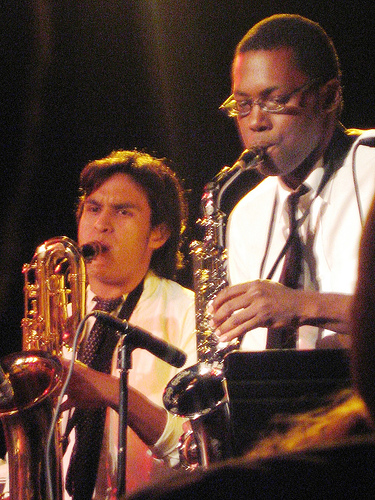<image>
Is there a saxophone in front of the man? No. The saxophone is not in front of the man. The spatial positioning shows a different relationship between these objects. 